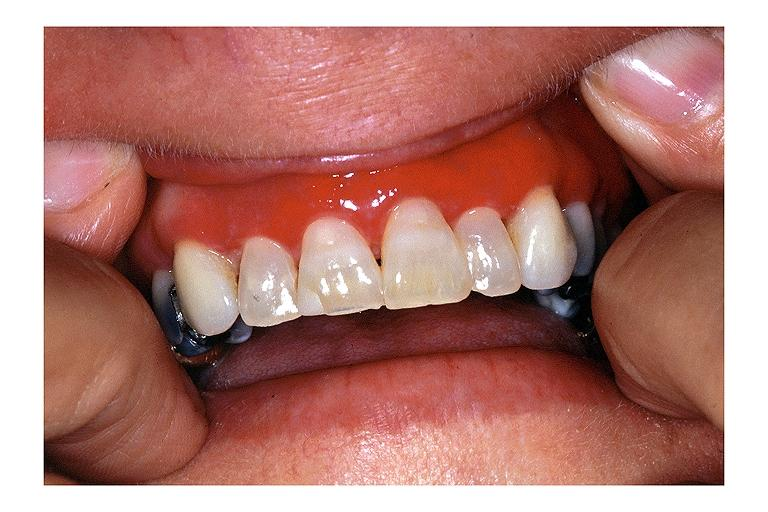where is this?
Answer the question using a single word or phrase. Oral 